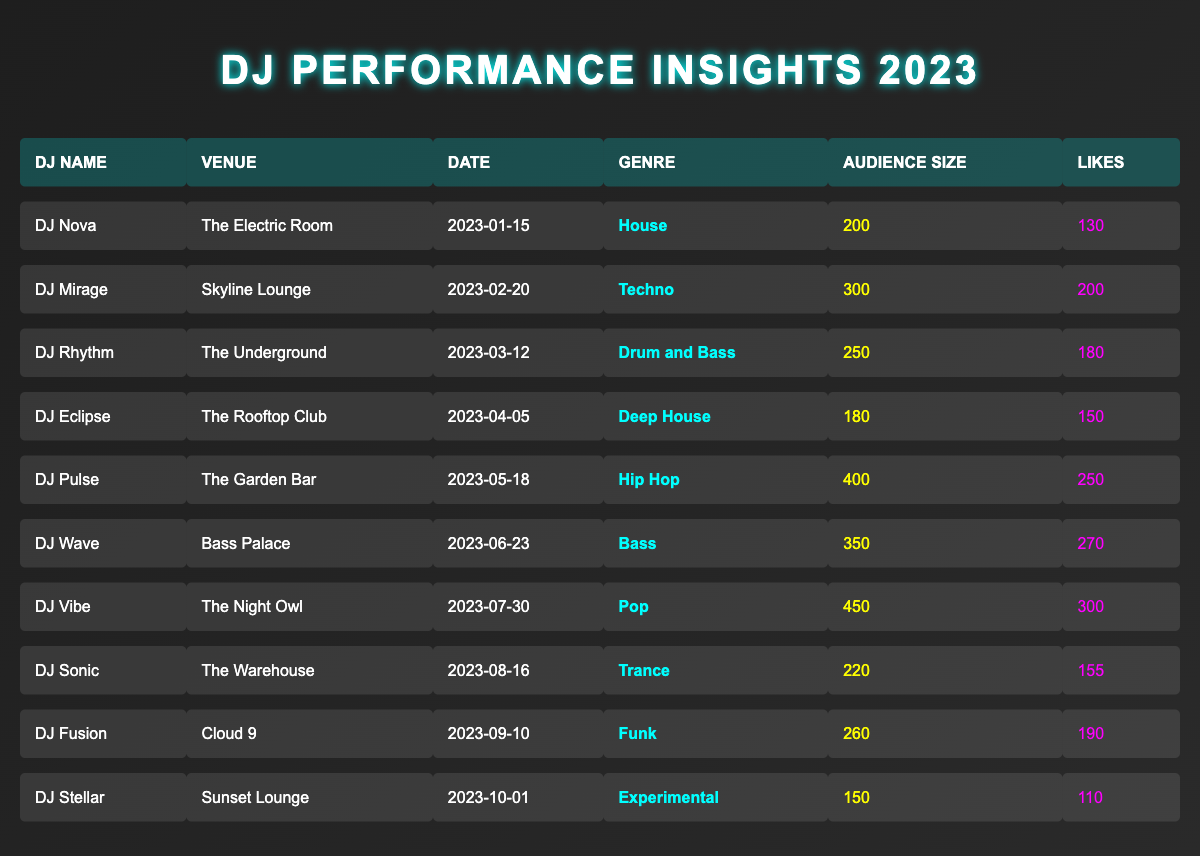What genre did DJ Pulse perform? By looking at the table, I can see that DJ Pulse is associated with the genre "Hip Hop" in his performance data.
Answer: Hip Hop Which DJ had the highest audience size? Reviewing the audience sizes, DJ Vibe had the largest audience at 450 people.
Answer: DJ Vibe What is the total number of likes for all performances? Summing the likes from each performance: (130 + 200 + 180 + 150 + 250 + 270 + 300 + 155 + 190 + 110) = 1985.
Answer: 1985 How many DJs performed in the genre "Bass"? Looking at the table, I see that only DJ Wave performed in the "Bass" genre.
Answer: 1 What genre had the most likes overall? First, I'll consider the likes per genre: Hip Hop (250), Bass (270), Pop (300), etc. The maximum likes come from the Pop genre with 300 likes.
Answer: Pop Did DJ Sonic have more likes than DJ Eclipse? DJ Sonic received 155 likes while DJ Eclipse had 150 likes, so yes, DJ Sonic had more likes than DJ Eclipse.
Answer: Yes What is the average audience size across all DJ performances? Adding the audience sizes: (200 + 300 + 250 + 180 + 400 + 350 + 450 + 220 + 260 + 150) = 2840. There are 10 performances, so the average audience size is 2840/10 = 284.
Answer: 284 Which DJ had the fewest likes, and how many were there? Looking at the likes, DJ Stellar had the least with 110 likes.
Answer: DJ Stellar; 110 Is there any DJ who performed at more than one venue? No, each DJ in the table is associated with a unique venue according to the data provided.
Answer: No What is the difference in audience size between the largest and smallest performance? The largest audience size was 450 (DJ Vibe) and the smallest was 150 (DJ Stellar). The difference is 450 - 150 = 300.
Answer: 300 